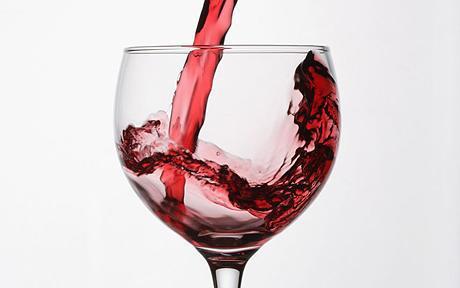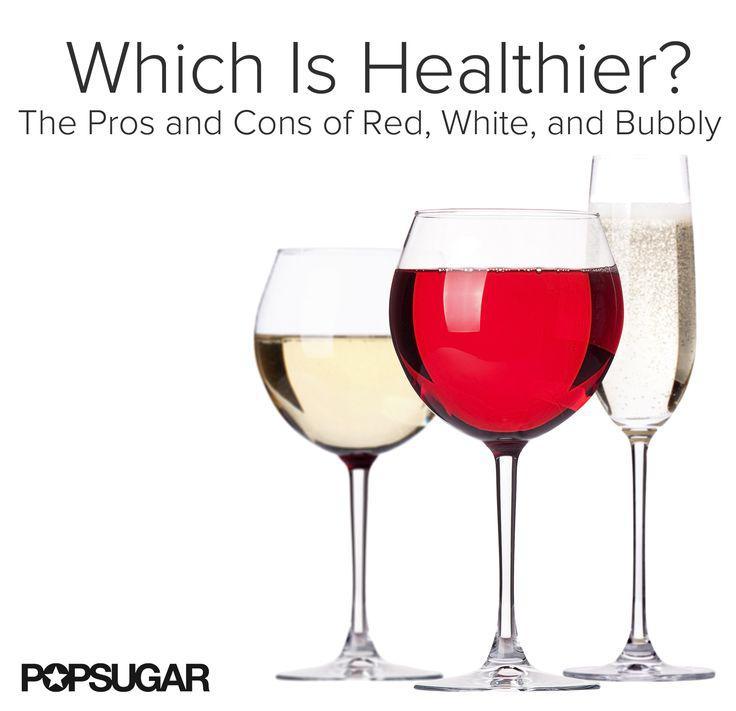The first image is the image on the left, the second image is the image on the right. Evaluate the accuracy of this statement regarding the images: "At least one of the images shows a sealed bottle of wine.". Is it true? Answer yes or no. No. 